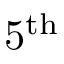Convert formula to latex. <formula><loc_0><loc_0><loc_500><loc_500>5 ^ { t h }</formula> 